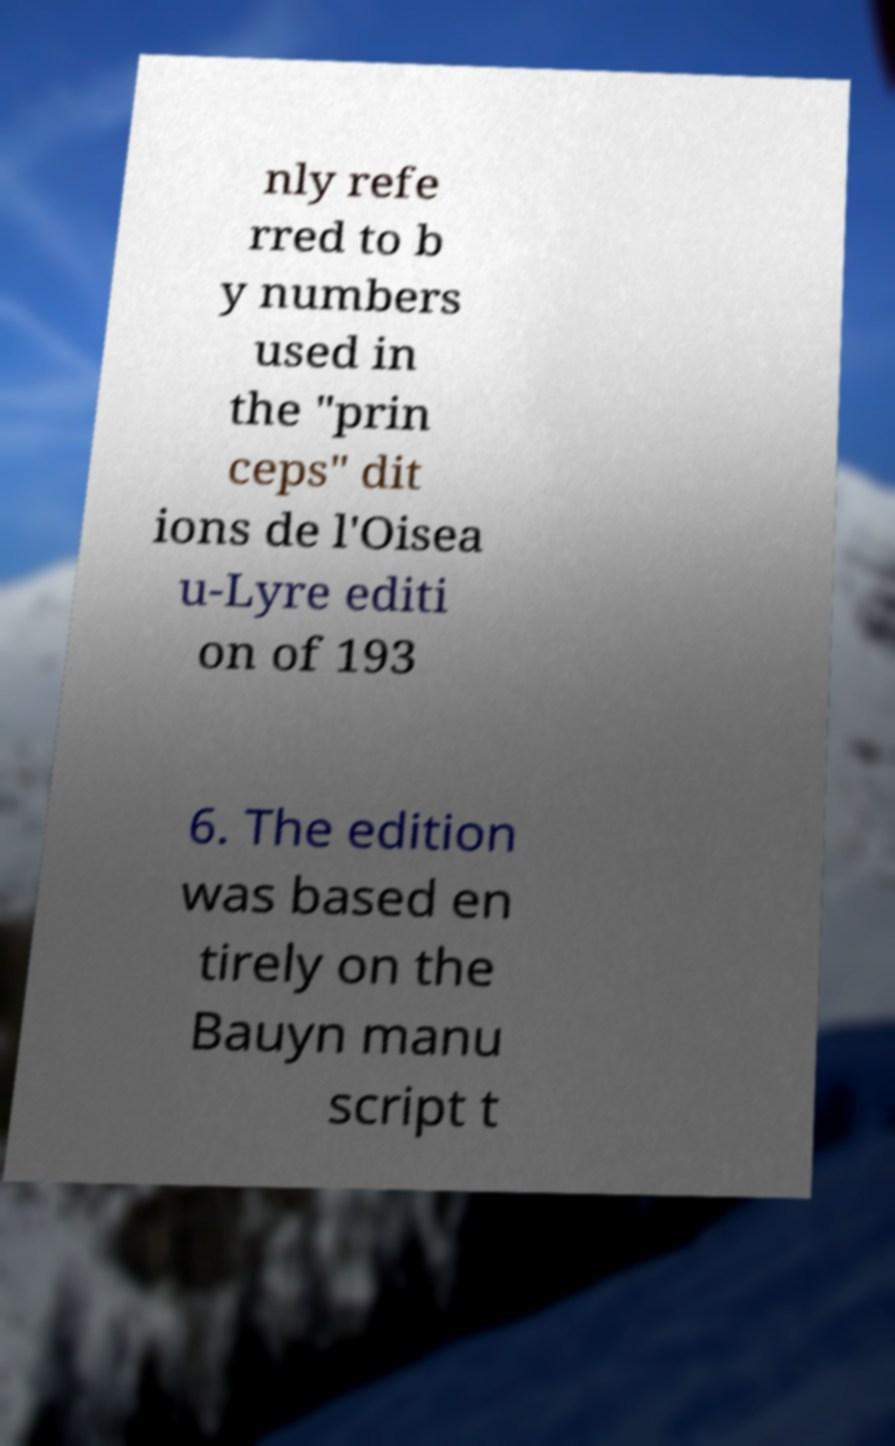Please identify and transcribe the text found in this image. nly refe rred to b y numbers used in the "prin ceps" dit ions de l'Oisea u-Lyre editi on of 193 6. The edition was based en tirely on the Bauyn manu script t 